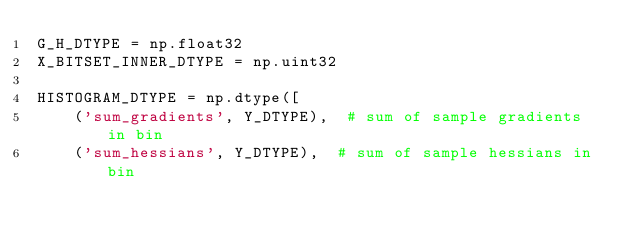<code> <loc_0><loc_0><loc_500><loc_500><_Cython_>G_H_DTYPE = np.float32
X_BITSET_INNER_DTYPE = np.uint32

HISTOGRAM_DTYPE = np.dtype([
    ('sum_gradients', Y_DTYPE),  # sum of sample gradients in bin
    ('sum_hessians', Y_DTYPE),  # sum of sample hessians in bin</code> 